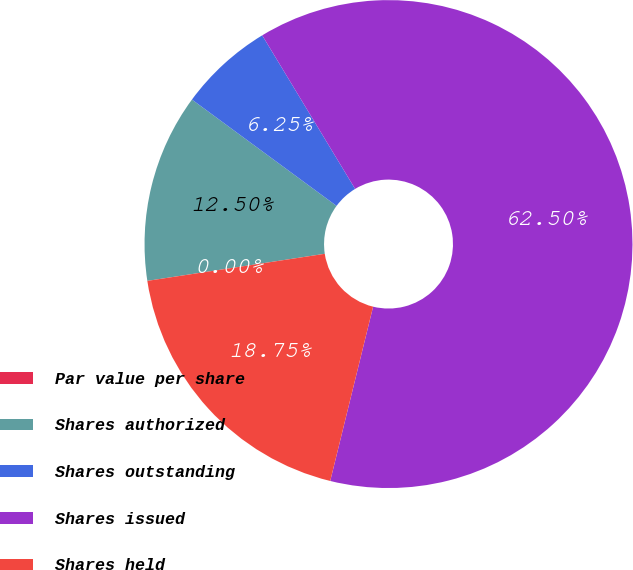<chart> <loc_0><loc_0><loc_500><loc_500><pie_chart><fcel>Par value per share<fcel>Shares authorized<fcel>Shares outstanding<fcel>Shares issued<fcel>Shares held<nl><fcel>0.0%<fcel>12.5%<fcel>6.25%<fcel>62.5%<fcel>18.75%<nl></chart> 